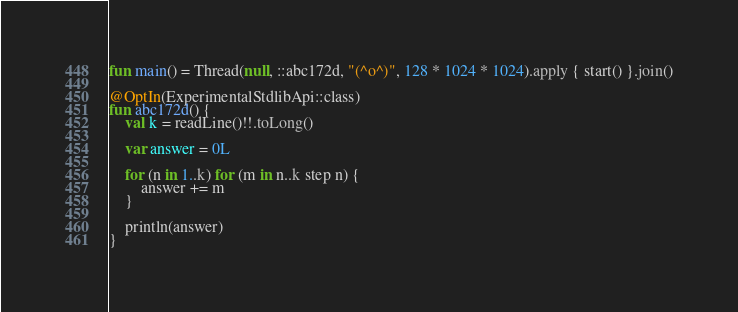<code> <loc_0><loc_0><loc_500><loc_500><_Kotlin_>fun main() = Thread(null, ::abc172d, "(^o^)", 128 * 1024 * 1024).apply { start() }.join()

@OptIn(ExperimentalStdlibApi::class)
fun abc172d() {
    val k = readLine()!!.toLong()

    var answer = 0L

    for (n in 1..k) for (m in n..k step n) {
        answer += m
    }

    println(answer)
}
</code> 